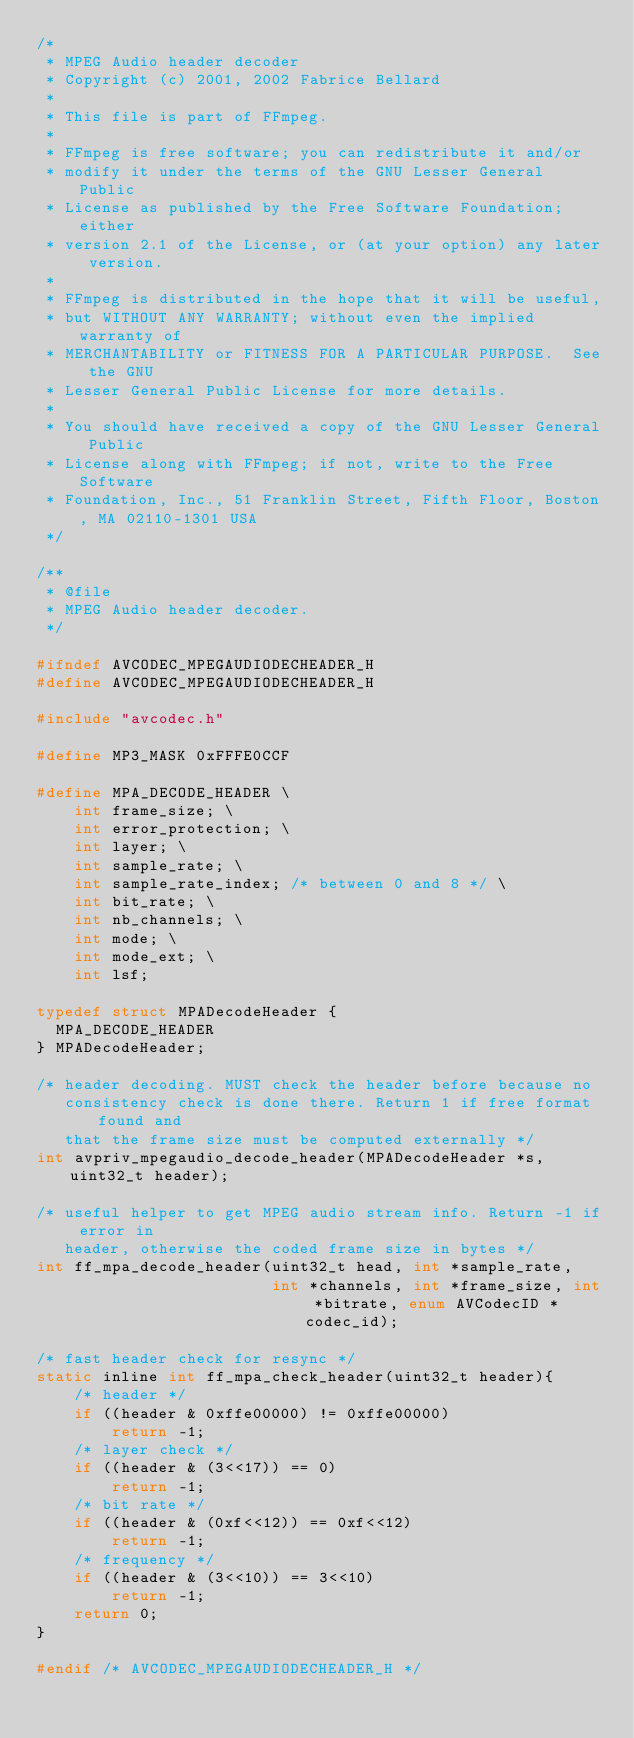<code> <loc_0><loc_0><loc_500><loc_500><_C_>/*
 * MPEG Audio header decoder
 * Copyright (c) 2001, 2002 Fabrice Bellard
 *
 * This file is part of FFmpeg.
 *
 * FFmpeg is free software; you can redistribute it and/or
 * modify it under the terms of the GNU Lesser General Public
 * License as published by the Free Software Foundation; either
 * version 2.1 of the License, or (at your option) any later version.
 *
 * FFmpeg is distributed in the hope that it will be useful,
 * but WITHOUT ANY WARRANTY; without even the implied warranty of
 * MERCHANTABILITY or FITNESS FOR A PARTICULAR PURPOSE.  See the GNU
 * Lesser General Public License for more details.
 *
 * You should have received a copy of the GNU Lesser General Public
 * License along with FFmpeg; if not, write to the Free Software
 * Foundation, Inc., 51 Franklin Street, Fifth Floor, Boston, MA 02110-1301 USA
 */

/**
 * @file
 * MPEG Audio header decoder.
 */

#ifndef AVCODEC_MPEGAUDIODECHEADER_H
#define AVCODEC_MPEGAUDIODECHEADER_H

#include "avcodec.h"

#define MP3_MASK 0xFFFE0CCF

#define MPA_DECODE_HEADER \
    int frame_size; \
    int error_protection; \
    int layer; \
    int sample_rate; \
    int sample_rate_index; /* between 0 and 8 */ \
    int bit_rate; \
    int nb_channels; \
    int mode; \
    int mode_ext; \
    int lsf;

typedef struct MPADecodeHeader {
  MPA_DECODE_HEADER
} MPADecodeHeader;

/* header decoding. MUST check the header before because no
   consistency check is done there. Return 1 if free format found and
   that the frame size must be computed externally */
int avpriv_mpegaudio_decode_header(MPADecodeHeader *s, uint32_t header);

/* useful helper to get MPEG audio stream info. Return -1 if error in
   header, otherwise the coded frame size in bytes */
int ff_mpa_decode_header(uint32_t head, int *sample_rate,
                         int *channels, int *frame_size, int *bitrate, enum AVCodecID *codec_id);

/* fast header check for resync */
static inline int ff_mpa_check_header(uint32_t header){
    /* header */
    if ((header & 0xffe00000) != 0xffe00000)
        return -1;
    /* layer check */
    if ((header & (3<<17)) == 0)
        return -1;
    /* bit rate */
    if ((header & (0xf<<12)) == 0xf<<12)
        return -1;
    /* frequency */
    if ((header & (3<<10)) == 3<<10)
        return -1;
    return 0;
}

#endif /* AVCODEC_MPEGAUDIODECHEADER_H */
</code> 